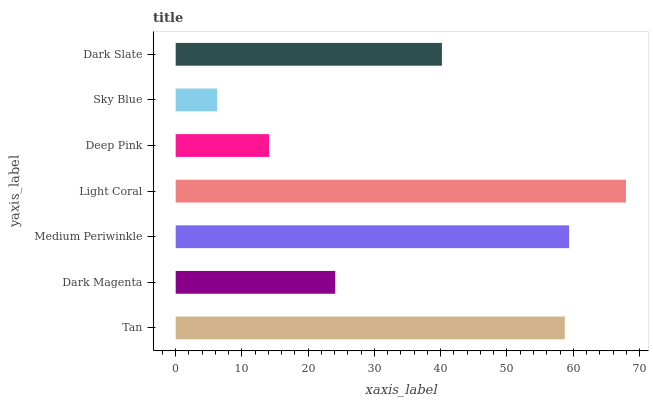Is Sky Blue the minimum?
Answer yes or no. Yes. Is Light Coral the maximum?
Answer yes or no. Yes. Is Dark Magenta the minimum?
Answer yes or no. No. Is Dark Magenta the maximum?
Answer yes or no. No. Is Tan greater than Dark Magenta?
Answer yes or no. Yes. Is Dark Magenta less than Tan?
Answer yes or no. Yes. Is Dark Magenta greater than Tan?
Answer yes or no. No. Is Tan less than Dark Magenta?
Answer yes or no. No. Is Dark Slate the high median?
Answer yes or no. Yes. Is Dark Slate the low median?
Answer yes or no. Yes. Is Sky Blue the high median?
Answer yes or no. No. Is Dark Magenta the low median?
Answer yes or no. No. 